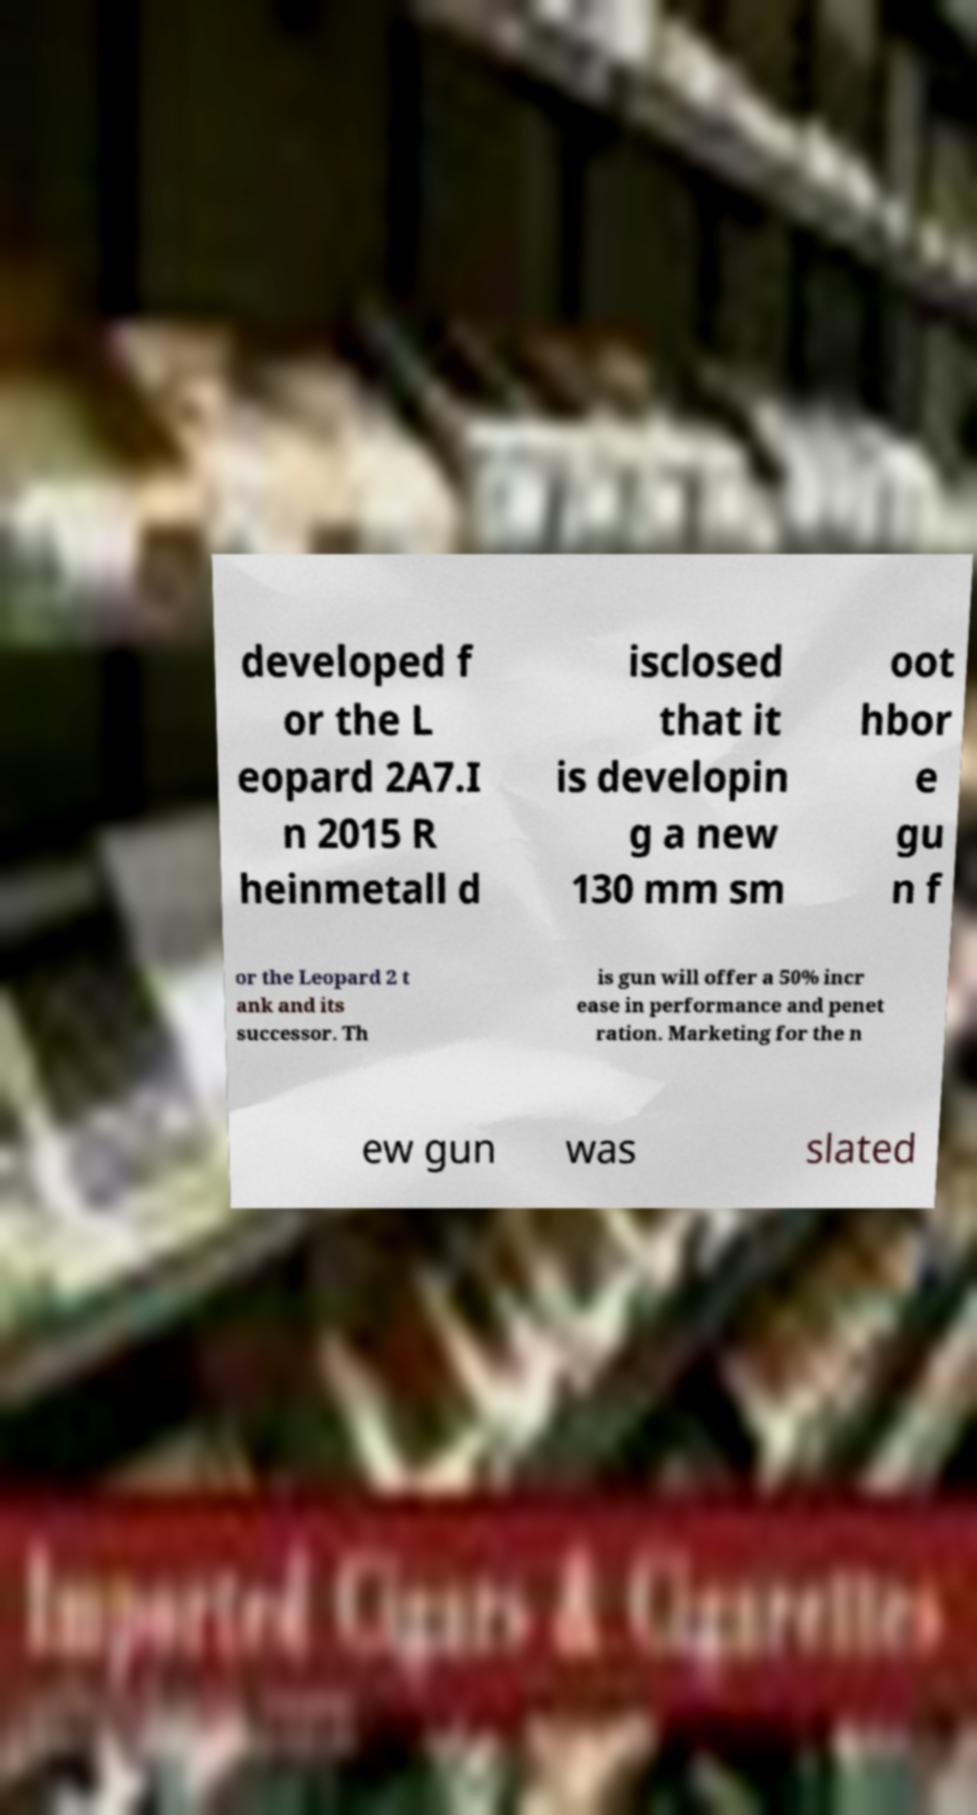I need the written content from this picture converted into text. Can you do that? developed f or the L eopard 2A7.I n 2015 R heinmetall d isclosed that it is developin g a new 130 mm sm oot hbor e gu n f or the Leopard 2 t ank and its successor. Th is gun will offer a 50% incr ease in performance and penet ration. Marketing for the n ew gun was slated 